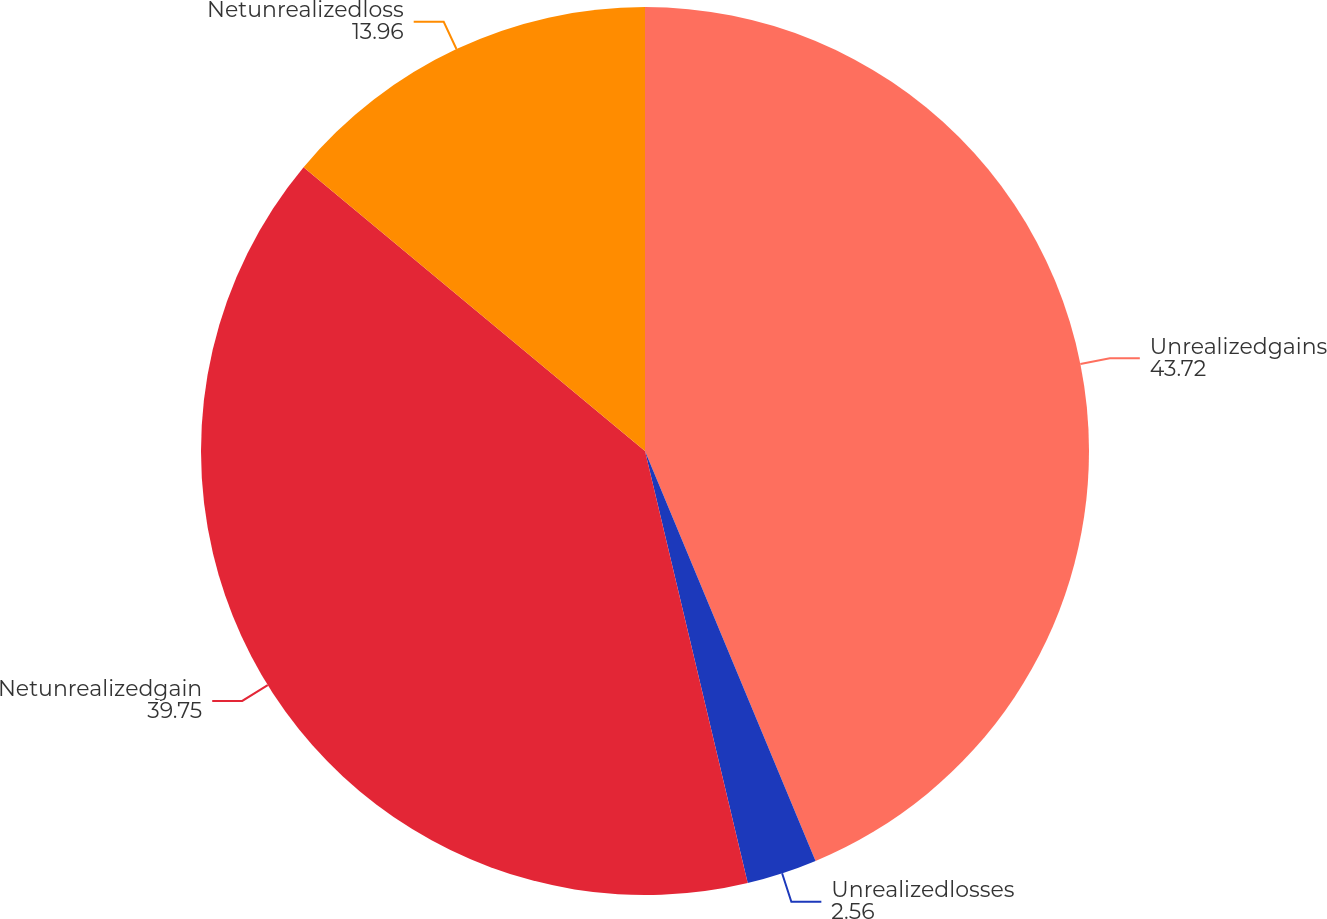Convert chart. <chart><loc_0><loc_0><loc_500><loc_500><pie_chart><fcel>Unrealizedgains<fcel>Unrealizedlosses<fcel>Netunrealizedgain<fcel>Netunrealizedloss<nl><fcel>43.72%<fcel>2.56%<fcel>39.75%<fcel>13.96%<nl></chart> 